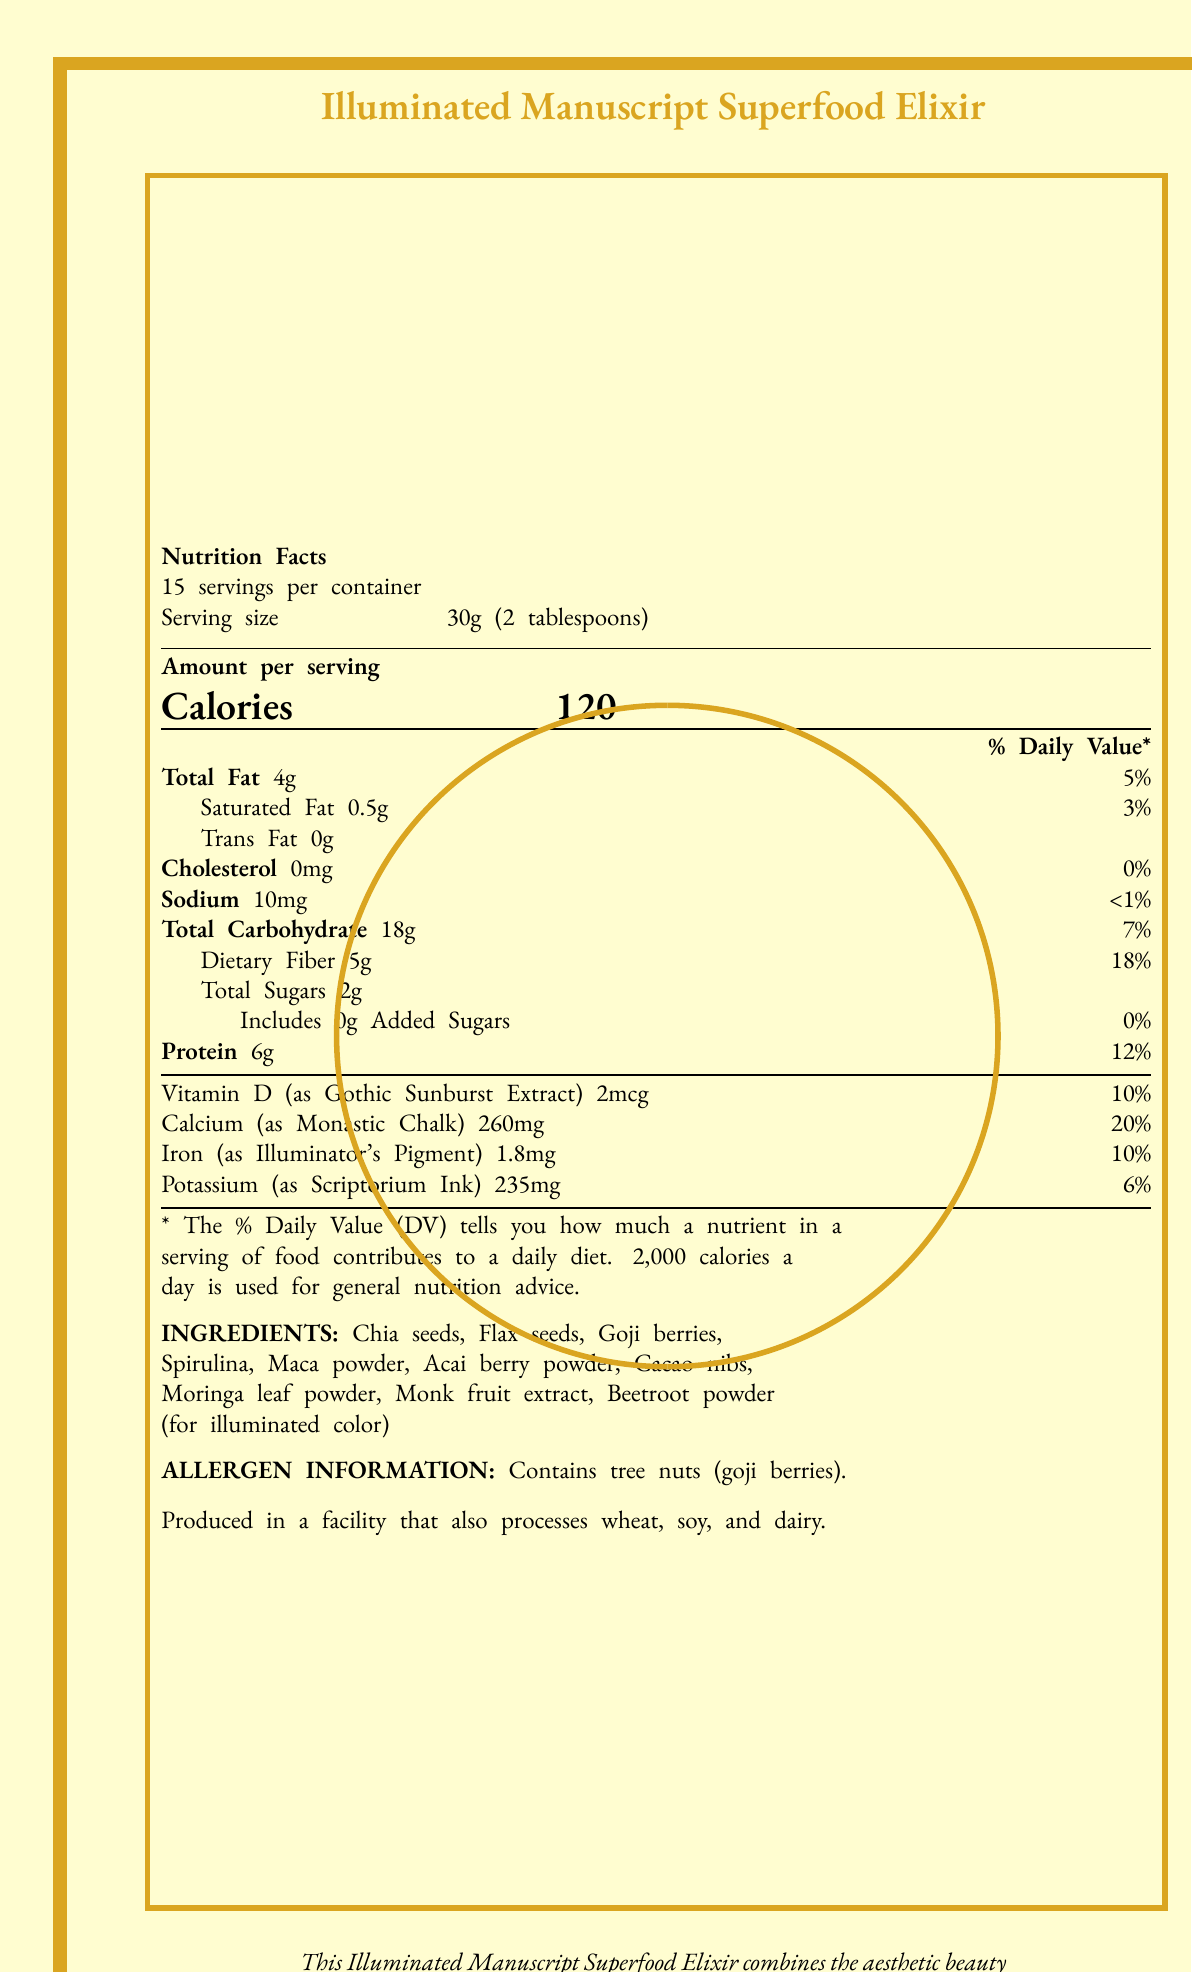what is the serving size? The serving size is clearly listed as "30g (2 tablespoons)" in the document.
Answer: 30g (2 tablespoons) how many calories are there per serving? The document states "Calories 120" per serving.
Answer: 120 which vitamins and minerals are included in the superfood mix? The vitamins and minerals listed in the document are Vitamin D, Calcium, Iron, and Potassium.
Answer: Vitamin D, Calcium, Iron, Potassium how much total fat is there per serving? The "Total Fat" content is specified as 4g per serving.
Answer: 4g what is the daily value percentage of dietary fiber per serving? The daily value percentage for dietary fiber is noted as 18%.
Answer: 18% what is the serving size of the Illuminated Manuscript Superfood Elixir? A. 20g B. 30g C. 50g D. 100g The serving size is listed as 30g (2 tablespoons).
Answer: B. 30g how many servings are there per container? A. 10 B. 12 C. 15 D. 20 The document states that there are 15 servings per container.
Answer: C. 15 is there any added sugar in the superfood mix? The document notes that added sugar is 0g.
Answer: No which of the following ingredients is NOT included in the Illuminated Manuscript Superfood Elixir? A. Chia Seeds B. Flax Seeds C. Quinoa D. Goji Berries The listed ingredients include Chia seeds, Flax seeds, Goji berries, etc., but Quinoa is not mentioned.
Answer: C. Quinoa does the superfood mix contain any cholesterol? The document shows that the cholesterol amount is 0mg.
Answer: No summarize the document. The document provides a comprehensive overview of the nutritional content and artistic design of the Illuminated Manuscript Superfood Elixir, highlighting its blend of historical artistry and modern nutrition.
Answer: The document is a detailed nutrition facts label for the Illuminated Manuscript Superfood Elixir, which combines the aesthetic elements of medieval manuscripts, such as ornate borders, decorated initials, and calligraphy, with the nutritional benefits of modern superfoods. It provides information on serving size, calories, total fat, cholesterol, sodium, total carbohydrates, dietary fiber, sugars, protein, and specific vitamins and minerals. It also lists ingredients and allergen information, emphasizing the influence of medieval manuscript art on the packaging design. what is the source of the beetroot powder color according to the document? The beetroot powder is mentioned specifically for its use "for illuminated color."
Answer: for illuminated color what percentage of daily value does Vitamin D contribute? The daily value percentage for Vitamin D is noted as 10%.
Answer: 10% how much calcium does one serving of the superfood mix provide? The document states that one serving provides 260mg of Calcium.
Answer: 260mg are the nutrient categories of the superfood mix depicted with decorated initials? The document mentions that each nutrient category begins with an elaborately illustrated initial letter, reminiscent of those found in the Book of Kells.
Answer: Yes what is the allergen information listed? The allergen information provided in the document states that the product contains tree nuts (goji berries) and is produced in a facility that processes wheat, soy, and dairy.
Answer: Contains tree nuts (goji berries). Produced in a facility that also processes wheat, soy, and dairy. how many grams of protein are in each serving? The document specifies that there are 6g of protein per serving.
Answer: 6g who designed the gothic textura script used in the document? The document does not provide information about the designer of the Gothic textura script.
Answer: Not enough information how many ingredients are listed in the superfood mix? There are 10 ingredients listed: Chia seeds, Flax seeds, Goji berries, Spirulina, Maca powder, Acai berry powder, Cacao nibs, Moringa leaf powder, Monk fruit extract, and Beetroot powder.
Answer: 10 